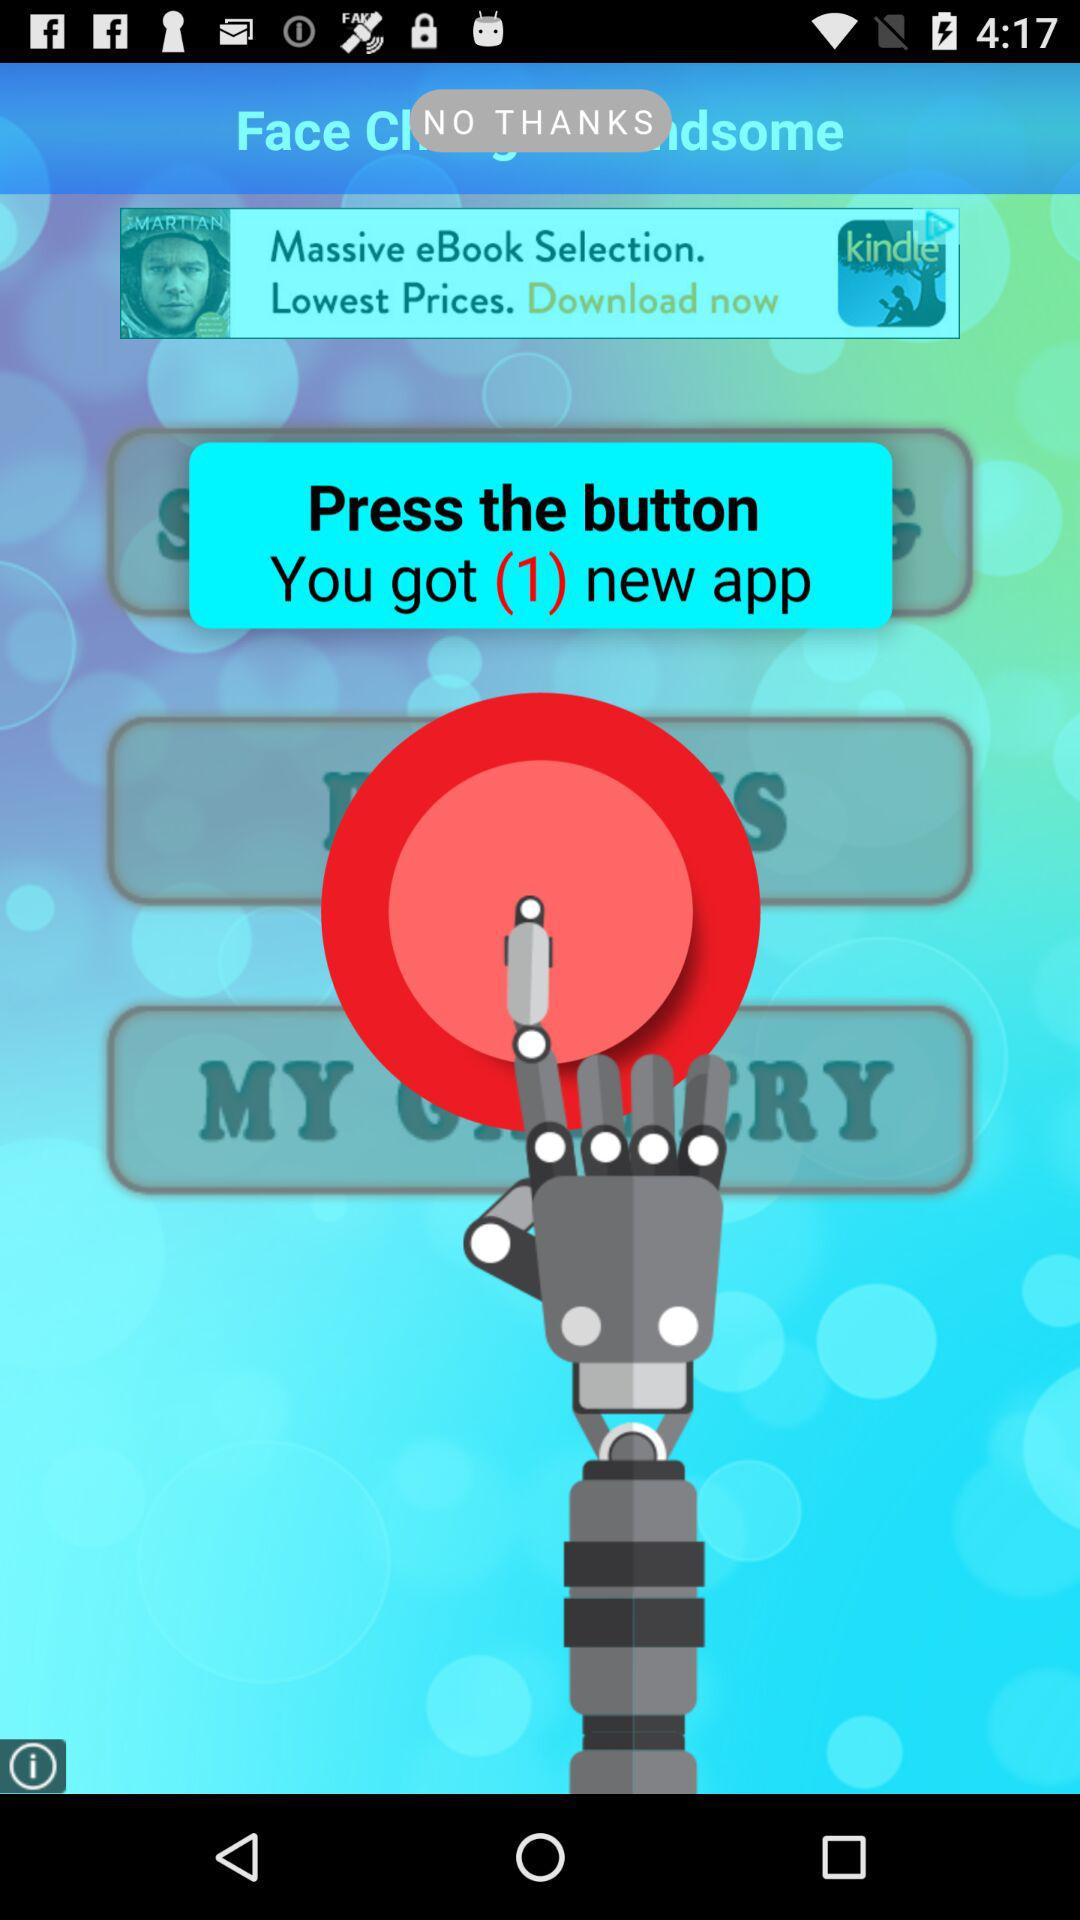How many new apps did we get? You got 1 new app. 